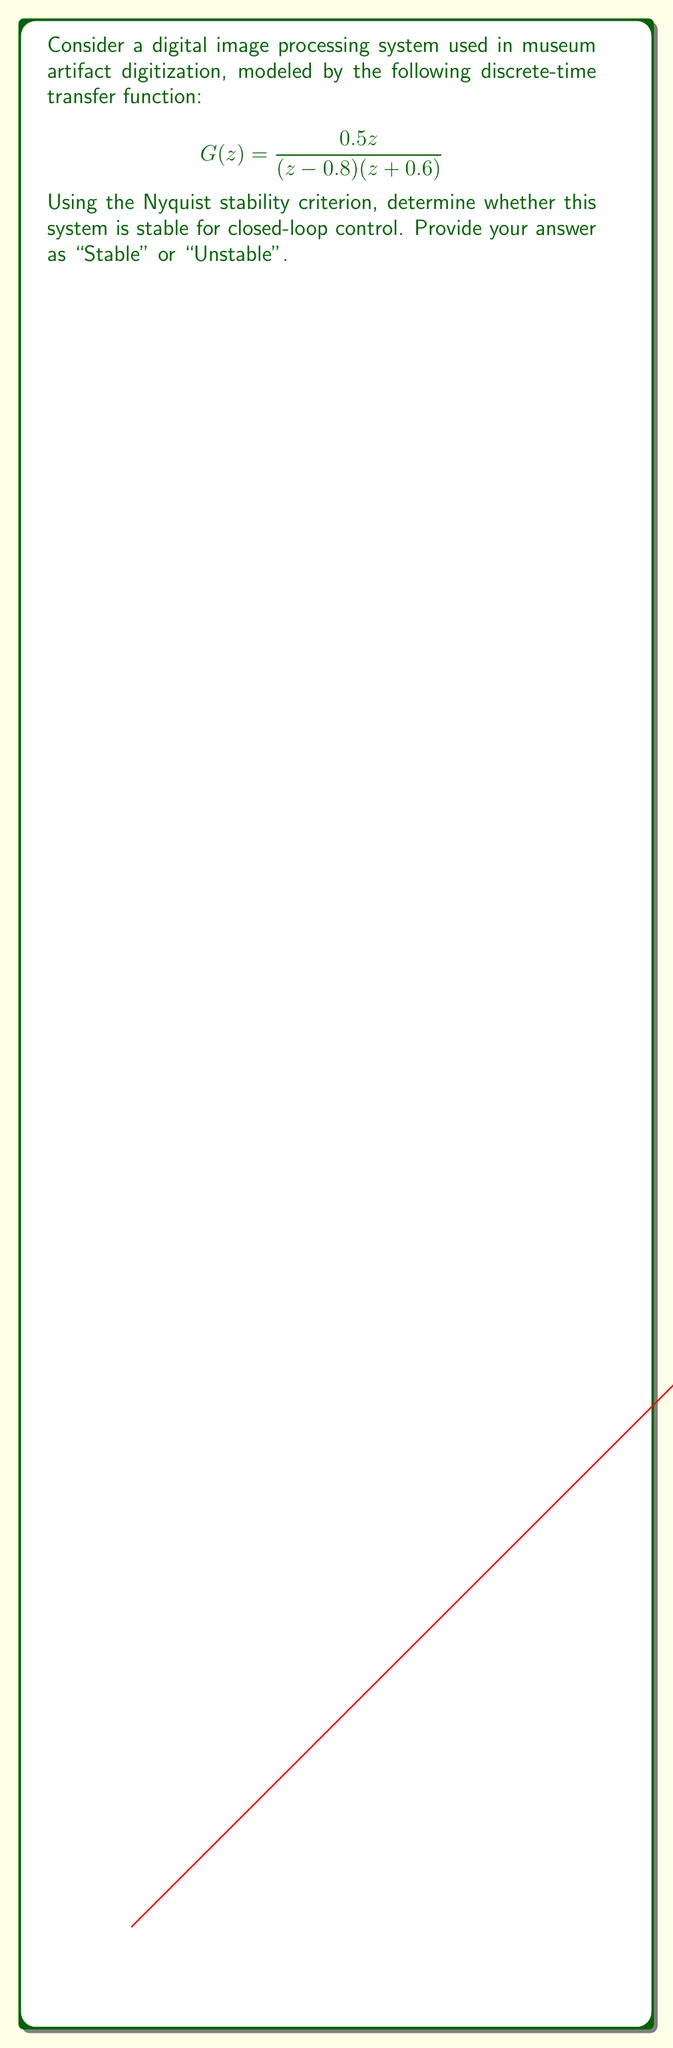Help me with this question. To determine the stability of the closed-loop system using the Nyquist stability criterion, we follow these steps:

1) First, we need to identify the number of open-loop poles outside the unit circle. In this case:
   $z_1 = 0.8$ (inside the unit circle)
   $z_2 = -0.6$ (inside the unit circle)
   So, P = 0 (no poles outside the unit circle)

2) Next, we evaluate the Nyquist plot of $G(z)$ as $z$ traverses the unit circle, i.e., $z = e^{j\omega}$ for $\omega \in [0, 2\pi]$.

3) We need to count the number of counterclockwise encirclements (N) of the point (-1, 0) by the Nyquist plot.

4) From the Nyquist plot (shown in the question), we can see that the curve does not encircle the point (-1, 0). Therefore, N = 0.

5) Apply the Nyquist stability criterion: For stability, we need:
   N + P = 0
   Where N is the number of counterclockwise encirclements of (-1, 0), and P is the number of open-loop poles outside the unit circle.

6) In our case:
   0 + 0 = 0

7) Since this equation is satisfied, the closed-loop system is stable.

This stability ensures that the digital image processing system will produce consistent and reliable results when processing digitized museum artifacts, which is crucial for maintaining the integrity of digital archives.
Answer: Stable 